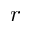<formula> <loc_0><loc_0><loc_500><loc_500>r</formula> 